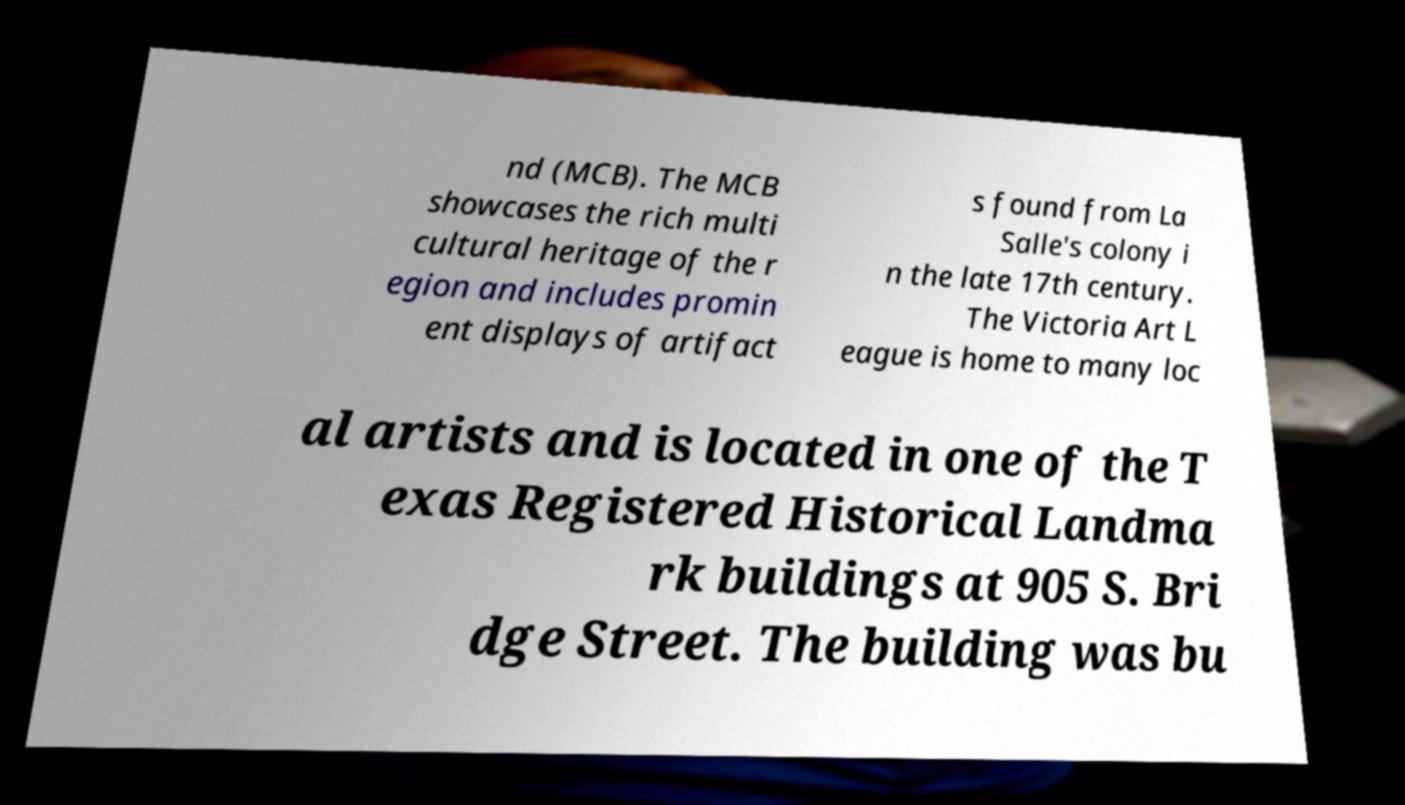There's text embedded in this image that I need extracted. Can you transcribe it verbatim? nd (MCB). The MCB showcases the rich multi cultural heritage of the r egion and includes promin ent displays of artifact s found from La Salle's colony i n the late 17th century. The Victoria Art L eague is home to many loc al artists and is located in one of the T exas Registered Historical Landma rk buildings at 905 S. Bri dge Street. The building was bu 